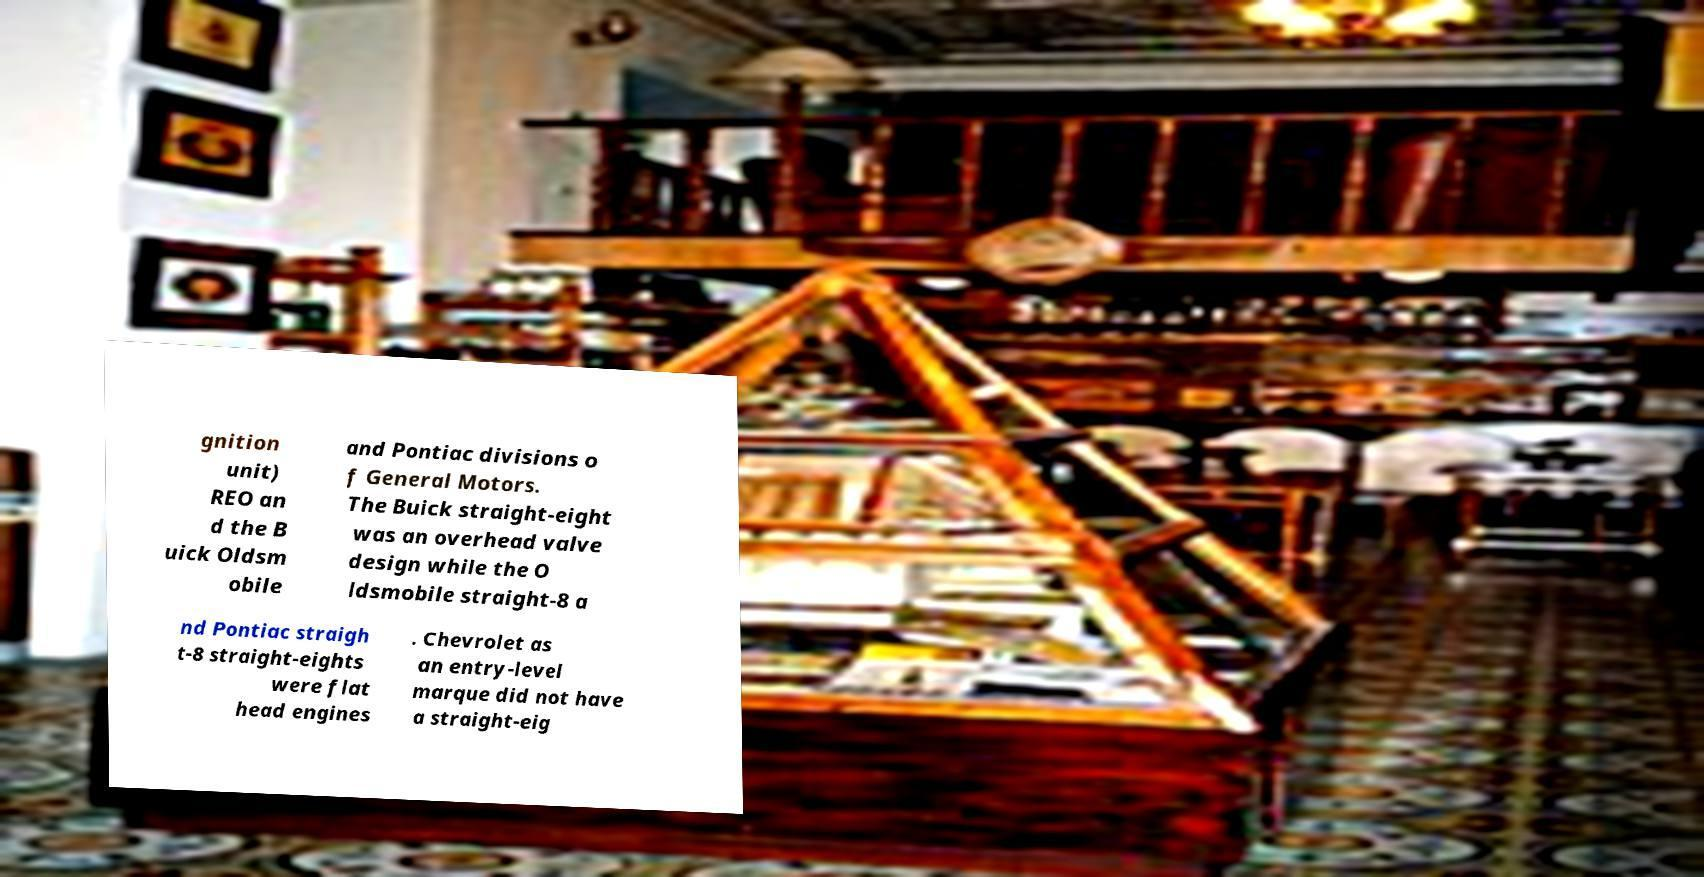Please read and relay the text visible in this image. What does it say? gnition unit) REO an d the B uick Oldsm obile and Pontiac divisions o f General Motors. The Buick straight-eight was an overhead valve design while the O ldsmobile straight-8 a nd Pontiac straigh t-8 straight-eights were flat head engines . Chevrolet as an entry-level marque did not have a straight-eig 